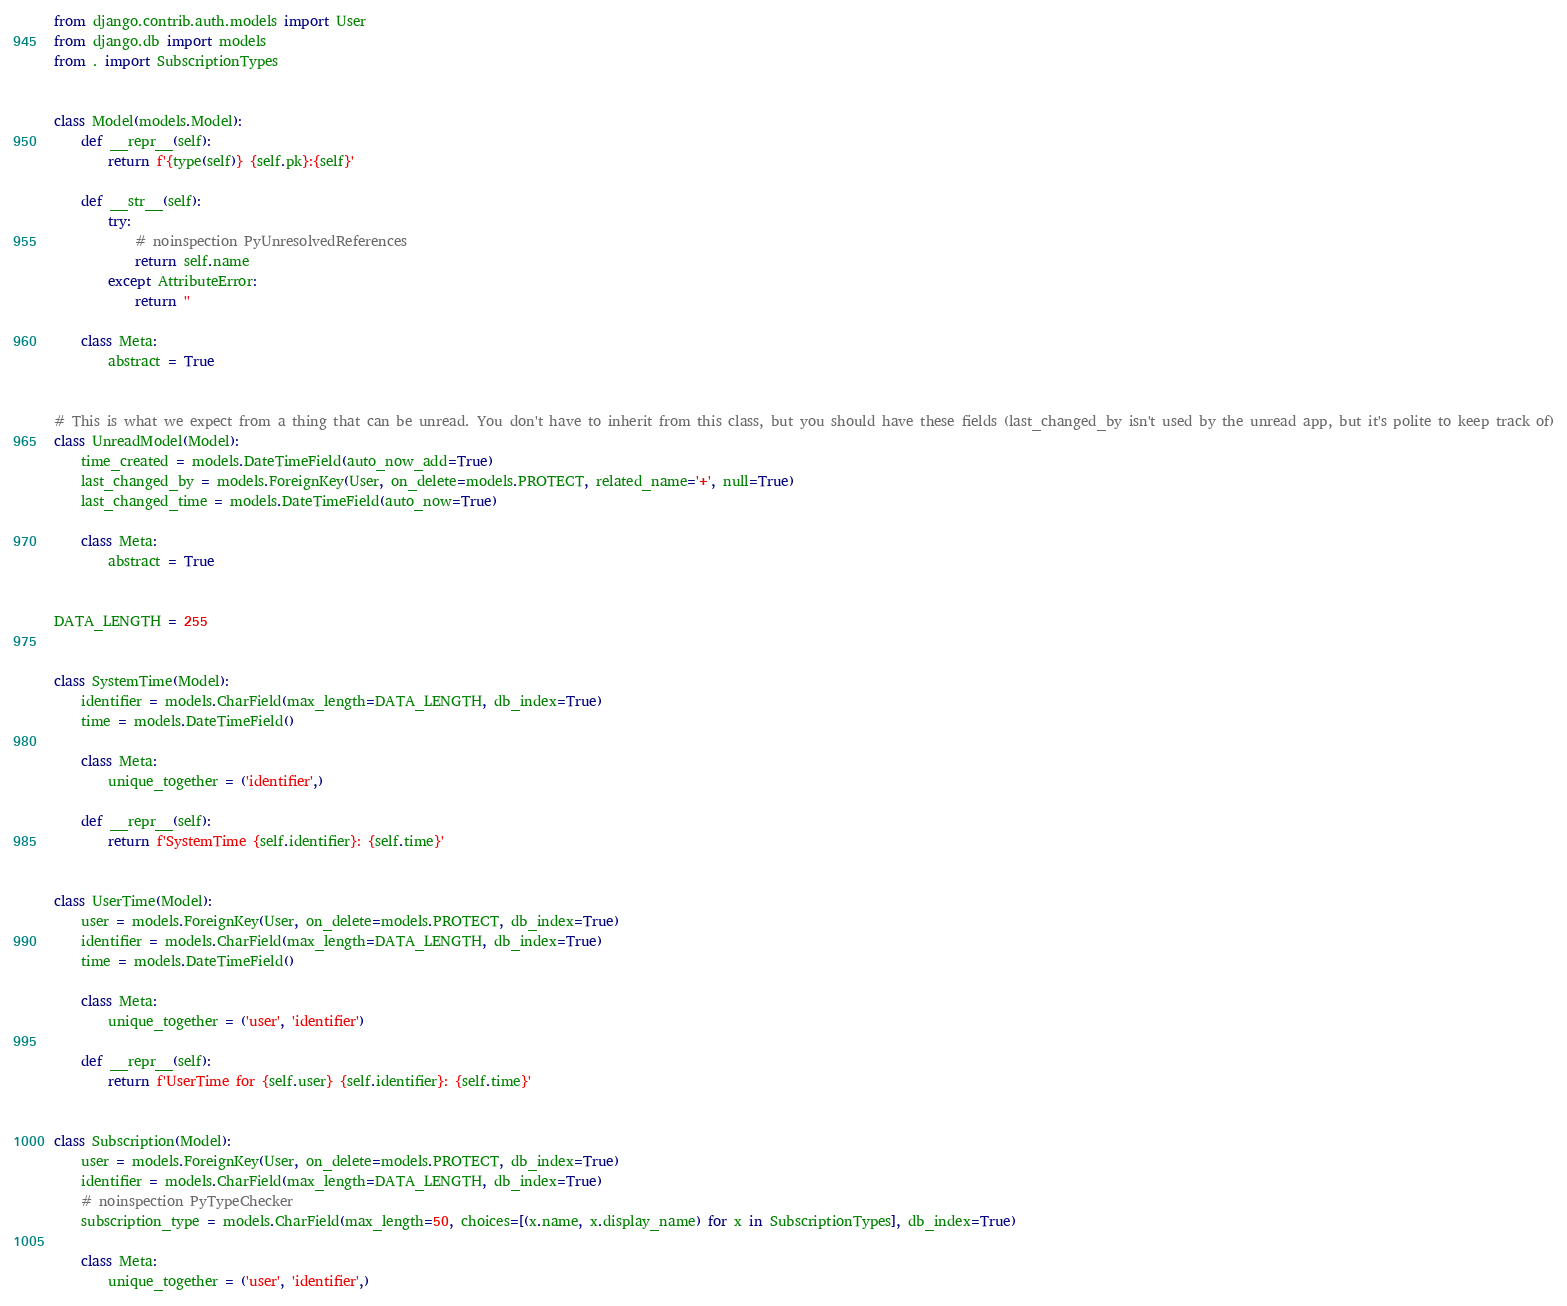Convert code to text. <code><loc_0><loc_0><loc_500><loc_500><_Python_>from django.contrib.auth.models import User
from django.db import models
from . import SubscriptionTypes


class Model(models.Model):
    def __repr__(self):
        return f'{type(self)} {self.pk}:{self}'

    def __str__(self):
        try:
            # noinspection PyUnresolvedReferences
            return self.name
        except AttributeError:
            return ''

    class Meta:
        abstract = True


# This is what we expect from a thing that can be unread. You don't have to inherit from this class, but you should have these fields (last_changed_by isn't used by the unread app, but it's polite to keep track of)
class UnreadModel(Model):
    time_created = models.DateTimeField(auto_now_add=True)
    last_changed_by = models.ForeignKey(User, on_delete=models.PROTECT, related_name='+', null=True)
    last_changed_time = models.DateTimeField(auto_now=True)

    class Meta:
        abstract = True


DATA_LENGTH = 255


class SystemTime(Model):
    identifier = models.CharField(max_length=DATA_LENGTH, db_index=True)
    time = models.DateTimeField()

    class Meta:
        unique_together = ('identifier',)

    def __repr__(self):
        return f'SystemTime {self.identifier}: {self.time}'


class UserTime(Model):
    user = models.ForeignKey(User, on_delete=models.PROTECT, db_index=True)
    identifier = models.CharField(max_length=DATA_LENGTH, db_index=True)
    time = models.DateTimeField()

    class Meta:
        unique_together = ('user', 'identifier')

    def __repr__(self):
        return f'UserTime for {self.user} {self.identifier}: {self.time}'


class Subscription(Model):
    user = models.ForeignKey(User, on_delete=models.PROTECT, db_index=True)
    identifier = models.CharField(max_length=DATA_LENGTH, db_index=True)
    # noinspection PyTypeChecker
    subscription_type = models.CharField(max_length=50, choices=[(x.name, x.display_name) for x in SubscriptionTypes], db_index=True)

    class Meta:
        unique_together = ('user', 'identifier',)
</code> 